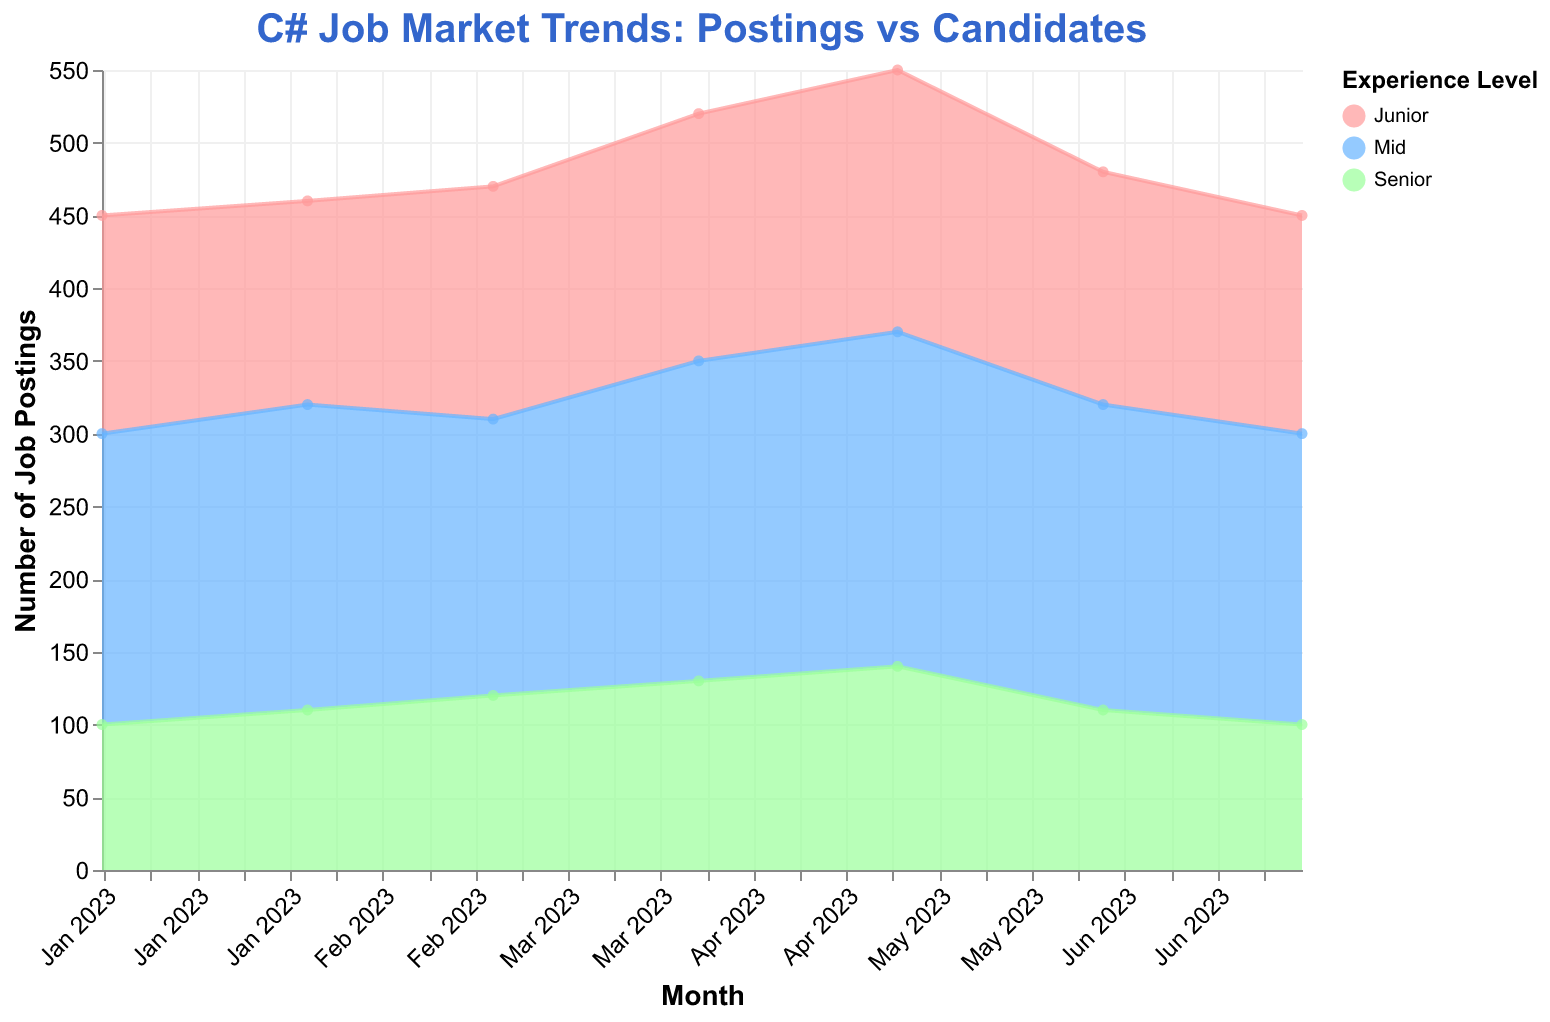What's the title of the chart? The title is usually located at the top of the chart and provides a summary of what the chart represents. In this case, the title is "C# Job Market Trends: Postings vs Candidates."
Answer: C# Job Market Trends: Postings vs Candidates Which month had the highest number of junior-level job postings? The highest point on the 'Junior' area indicates the month with the maximum job postings for junior-level positions. By looking at the Junior trend line, the peak is in May 2023 with 180 job postings.
Answer: May 2023 How did the number of senior-level job postings change from January to July 2023? To discern changes over time, trace the 'Senior' trend line from January to July. We see that job postings started at 100 in January, slightly increased to 110 in February, 120 in March, 130 in April, 140 in May, decreased back to 110 in June, and dropped again to 100 in July.
Answer: Stayed the same (100 to 100) What's the overall trend observed for mid-level job postings from January to July 2023? Observing the 'Mid' trend line, we see modest fluctuations. In January, there were 200 postings, increasing to 210 in February, dropping to 190 in March, rising progressively to 220 in April and 230 in May, decreasing to 210 in June, and finally, slightly declining to 200 in July. Overall trend shows some fluctuation but mainly increase and then a slight fall.
Answer: Mostly increasing with slight fluctuations Compare the number of candidates applying for mid-level positions in March and April 2023. Which month had more applicants, and by how much? Review the data points for 'Candidates Applying' in the Mid experience level for both March and April. In March, 210 candidates applied, and in April, 240 candidates applied. To find the difference: 240 - 210 = 30.
Answer: April by 30 What is the average number of job postings for junior positions over the given period? Sum the monthly job postings for Junior: 150+140+160+170+180+160+150 = 1110. Then, divide by the number of months (7): 1110/7 = 158.57.
Answer: 158.57 In which month did mid-level and senior-level candidate applications show a significant difference, and what was the difference? Compare the 'Candidates Applying' data for Mid and Senior levels month by month to identify significant disparities. The largest difference is found in April, with 240 mid-level applications and 120 senior-level applications. Difference: 240 - 120 = 120.
Answer: April, 120 How often do candidate applications exceed job postings for senior positions? Analyze the trend lines for Senior 'Candidates Applying' and 'Job Postings.' The applications exceed job postings in March (110 vs. 120), April (120 vs. 130), and May (130 vs. 140). Therefore, it happens 3 times.
Answer: 3 times 